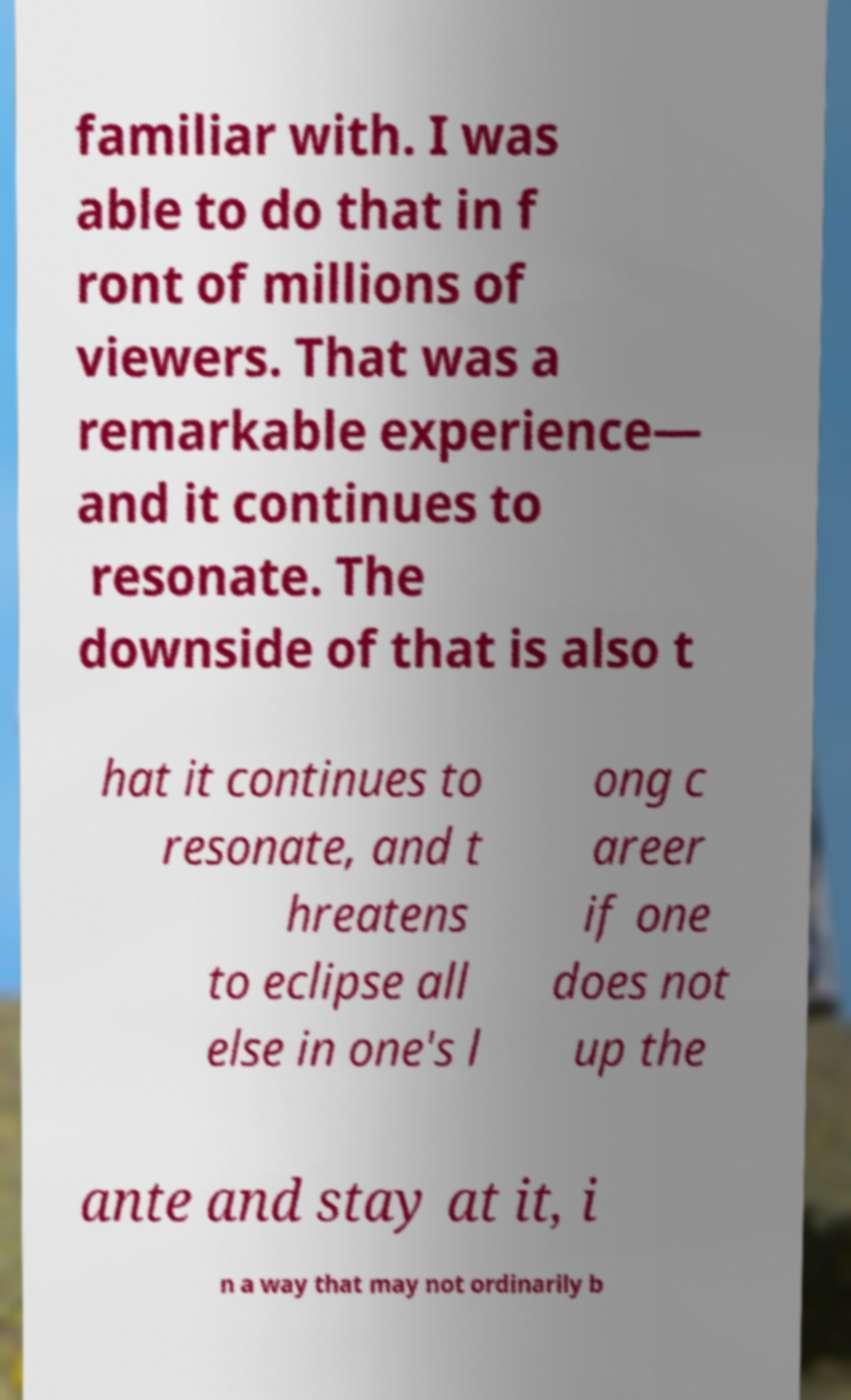Can you accurately transcribe the text from the provided image for me? familiar with. I was able to do that in f ront of millions of viewers. That was a remarkable experience— and it continues to resonate. The downside of that is also t hat it continues to resonate, and t hreatens to eclipse all else in one's l ong c areer if one does not up the ante and stay at it, i n a way that may not ordinarily b 